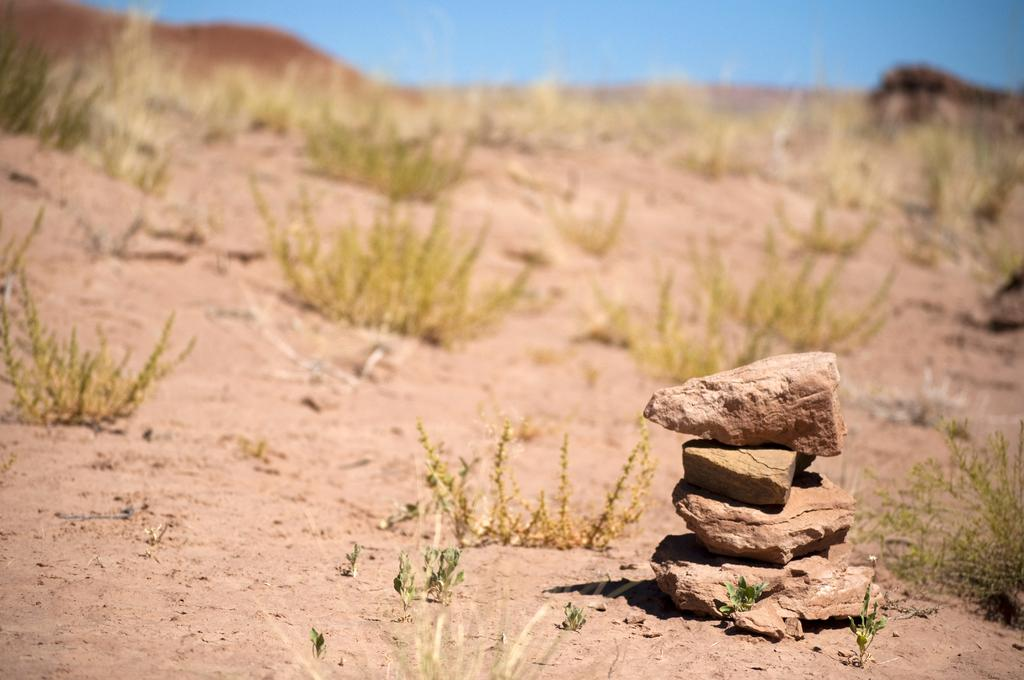What is the main subject of the image? The main subject of the image is stones placed one on the other. Where are the stones located? The stones are on the ground. What else can be seen in the image besides the stones? There are plants and the sky visible in the image. What type of root can be seen growing from the stomach of the stone in the image? There is no root or stomach present in the image, as the main subject is stones placed one on the other. 